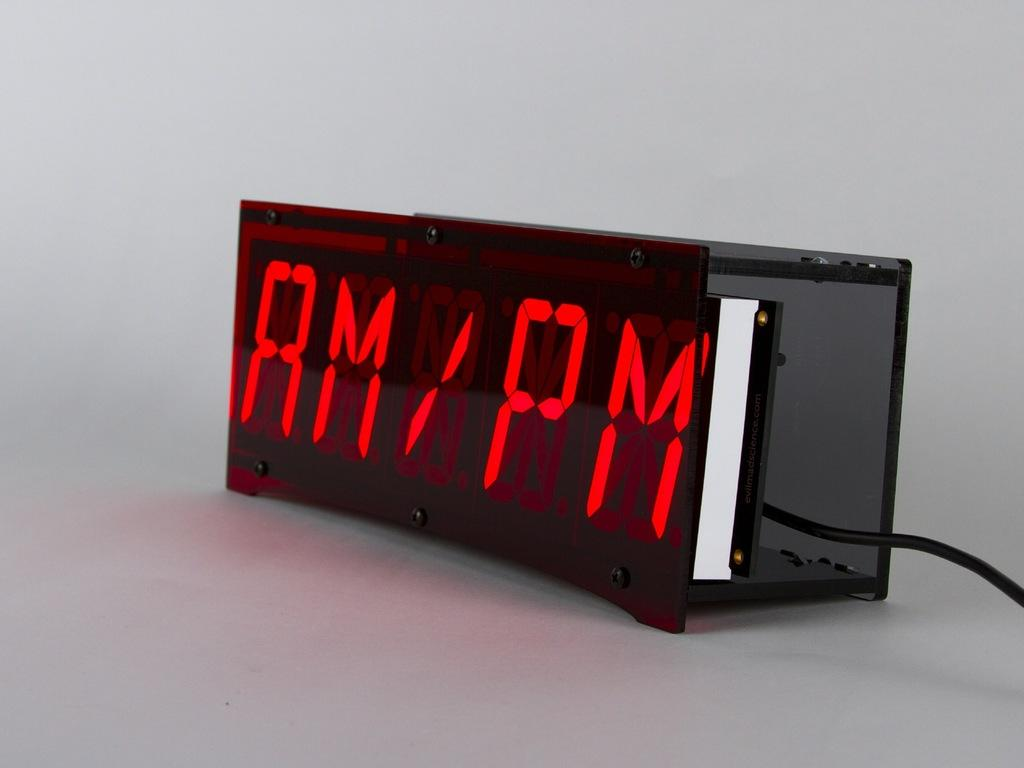<image>
Offer a succinct explanation of the picture presented. A digital clock with "AM/PM" on the display. 